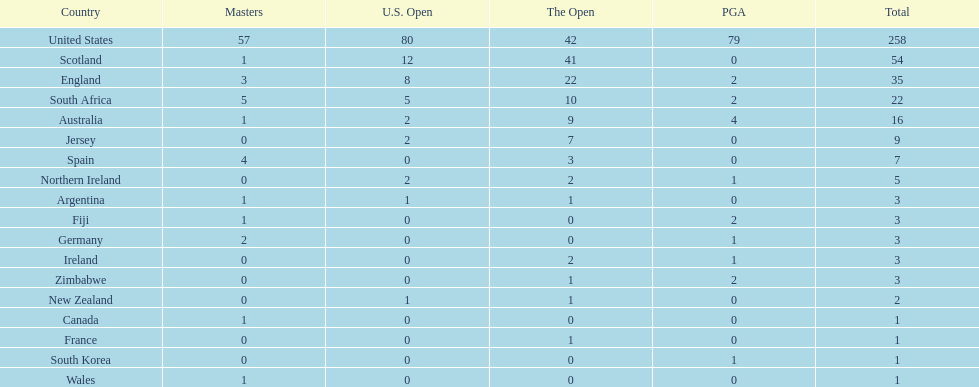Could you help me parse every detail presented in this table? {'header': ['Country', 'Masters', 'U.S. Open', 'The Open', 'PGA', 'Total'], 'rows': [['United States', '57', '80', '42', '79', '258'], ['Scotland', '1', '12', '41', '0', '54'], ['England', '3', '8', '22', '2', '35'], ['South Africa', '5', '5', '10', '2', '22'], ['Australia', '1', '2', '9', '4', '16'], ['Jersey', '0', '2', '7', '0', '9'], ['Spain', '4', '0', '3', '0', '7'], ['Northern Ireland', '0', '2', '2', '1', '5'], ['Argentina', '1', '1', '1', '0', '3'], ['Fiji', '1', '0', '0', '2', '3'], ['Germany', '2', '0', '0', '1', '3'], ['Ireland', '0', '0', '2', '1', '3'], ['Zimbabwe', '0', '0', '1', '2', '3'], ['New Zealand', '0', '1', '1', '0', '2'], ['Canada', '1', '0', '0', '0', '1'], ['France', '0', '0', '1', '0', '1'], ['South Korea', '0', '0', '0', '1', '1'], ['Wales', '1', '0', '0', '0', '1']]} How many total championships does spain have? 7. 